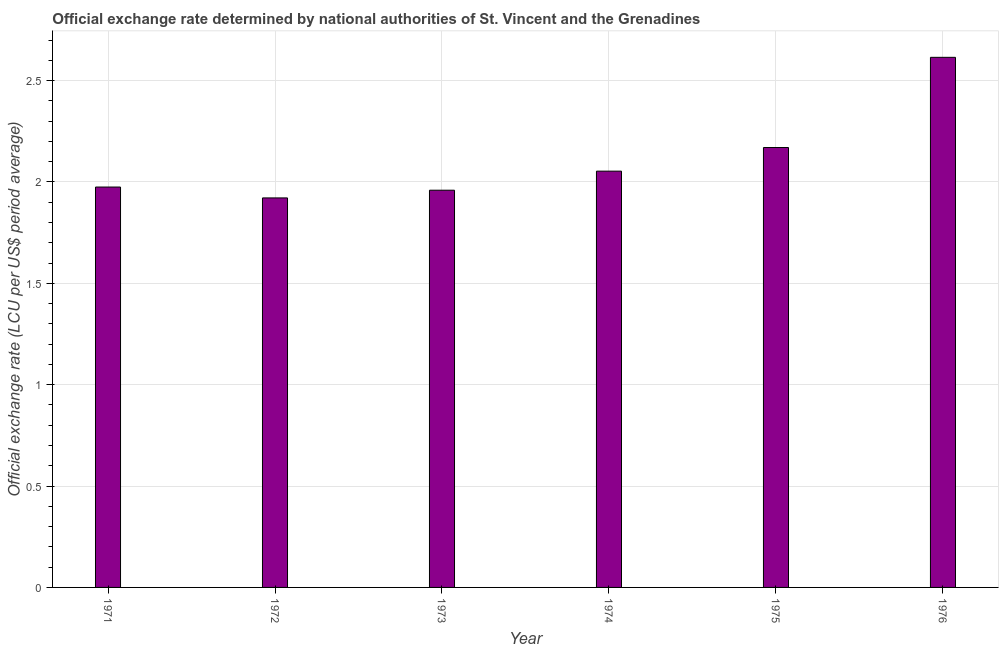What is the title of the graph?
Give a very brief answer. Official exchange rate determined by national authorities of St. Vincent and the Grenadines. What is the label or title of the X-axis?
Ensure brevity in your answer.  Year. What is the label or title of the Y-axis?
Give a very brief answer. Official exchange rate (LCU per US$ period average). What is the official exchange rate in 1971?
Your answer should be compact. 1.97. Across all years, what is the maximum official exchange rate?
Your answer should be compact. 2.61. Across all years, what is the minimum official exchange rate?
Your answer should be compact. 1.92. In which year was the official exchange rate maximum?
Your answer should be compact. 1976. What is the sum of the official exchange rate?
Give a very brief answer. 12.69. What is the difference between the official exchange rate in 1971 and 1972?
Your answer should be very brief. 0.05. What is the average official exchange rate per year?
Your answer should be very brief. 2.12. What is the median official exchange rate?
Give a very brief answer. 2.01. Do a majority of the years between 1974 and 1973 (inclusive) have official exchange rate greater than 0.6 ?
Keep it short and to the point. No. What is the ratio of the official exchange rate in 1973 to that in 1976?
Provide a succinct answer. 0.75. Is the official exchange rate in 1971 less than that in 1974?
Your response must be concise. Yes. What is the difference between the highest and the second highest official exchange rate?
Provide a succinct answer. 0.45. What is the difference between the highest and the lowest official exchange rate?
Provide a succinct answer. 0.69. How many bars are there?
Offer a terse response. 6. Are all the bars in the graph horizontal?
Ensure brevity in your answer.  No. How many years are there in the graph?
Give a very brief answer. 6. What is the Official exchange rate (LCU per US$ period average) of 1971?
Keep it short and to the point. 1.97. What is the Official exchange rate (LCU per US$ period average) of 1972?
Offer a very short reply. 1.92. What is the Official exchange rate (LCU per US$ period average) of 1973?
Provide a succinct answer. 1.96. What is the Official exchange rate (LCU per US$ period average) of 1974?
Make the answer very short. 2.05. What is the Official exchange rate (LCU per US$ period average) in 1975?
Make the answer very short. 2.17. What is the Official exchange rate (LCU per US$ period average) of 1976?
Offer a terse response. 2.61. What is the difference between the Official exchange rate (LCU per US$ period average) in 1971 and 1972?
Offer a very short reply. 0.05. What is the difference between the Official exchange rate (LCU per US$ period average) in 1971 and 1973?
Your answer should be compact. 0.02. What is the difference between the Official exchange rate (LCU per US$ period average) in 1971 and 1974?
Your response must be concise. -0.08. What is the difference between the Official exchange rate (LCU per US$ period average) in 1971 and 1975?
Offer a very short reply. -0.19. What is the difference between the Official exchange rate (LCU per US$ period average) in 1971 and 1976?
Keep it short and to the point. -0.64. What is the difference between the Official exchange rate (LCU per US$ period average) in 1972 and 1973?
Your answer should be compact. -0.04. What is the difference between the Official exchange rate (LCU per US$ period average) in 1972 and 1974?
Provide a succinct answer. -0.13. What is the difference between the Official exchange rate (LCU per US$ period average) in 1972 and 1975?
Offer a very short reply. -0.25. What is the difference between the Official exchange rate (LCU per US$ period average) in 1972 and 1976?
Provide a succinct answer. -0.69. What is the difference between the Official exchange rate (LCU per US$ period average) in 1973 and 1974?
Provide a succinct answer. -0.09. What is the difference between the Official exchange rate (LCU per US$ period average) in 1973 and 1975?
Ensure brevity in your answer.  -0.21. What is the difference between the Official exchange rate (LCU per US$ period average) in 1973 and 1976?
Ensure brevity in your answer.  -0.66. What is the difference between the Official exchange rate (LCU per US$ period average) in 1974 and 1975?
Your answer should be compact. -0.12. What is the difference between the Official exchange rate (LCU per US$ period average) in 1974 and 1976?
Offer a terse response. -0.56. What is the difference between the Official exchange rate (LCU per US$ period average) in 1975 and 1976?
Offer a very short reply. -0.44. What is the ratio of the Official exchange rate (LCU per US$ period average) in 1971 to that in 1972?
Your answer should be very brief. 1.03. What is the ratio of the Official exchange rate (LCU per US$ period average) in 1971 to that in 1973?
Give a very brief answer. 1.01. What is the ratio of the Official exchange rate (LCU per US$ period average) in 1971 to that in 1974?
Provide a short and direct response. 0.96. What is the ratio of the Official exchange rate (LCU per US$ period average) in 1971 to that in 1975?
Offer a terse response. 0.91. What is the ratio of the Official exchange rate (LCU per US$ period average) in 1971 to that in 1976?
Offer a terse response. 0.76. What is the ratio of the Official exchange rate (LCU per US$ period average) in 1972 to that in 1973?
Offer a very short reply. 0.98. What is the ratio of the Official exchange rate (LCU per US$ period average) in 1972 to that in 1974?
Offer a terse response. 0.94. What is the ratio of the Official exchange rate (LCU per US$ period average) in 1972 to that in 1975?
Your answer should be compact. 0.89. What is the ratio of the Official exchange rate (LCU per US$ period average) in 1972 to that in 1976?
Provide a succinct answer. 0.73. What is the ratio of the Official exchange rate (LCU per US$ period average) in 1973 to that in 1974?
Provide a short and direct response. 0.95. What is the ratio of the Official exchange rate (LCU per US$ period average) in 1973 to that in 1975?
Provide a succinct answer. 0.9. What is the ratio of the Official exchange rate (LCU per US$ period average) in 1973 to that in 1976?
Your response must be concise. 0.75. What is the ratio of the Official exchange rate (LCU per US$ period average) in 1974 to that in 1975?
Your answer should be compact. 0.95. What is the ratio of the Official exchange rate (LCU per US$ period average) in 1974 to that in 1976?
Provide a succinct answer. 0.79. What is the ratio of the Official exchange rate (LCU per US$ period average) in 1975 to that in 1976?
Your answer should be compact. 0.83. 